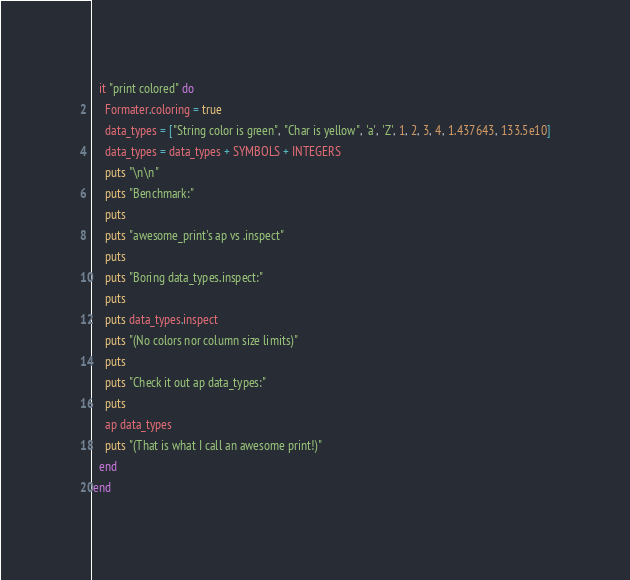Convert code to text. <code><loc_0><loc_0><loc_500><loc_500><_Crystal_>  it "print colored" do
    Formater.coloring = true
    data_types = ["String color is green", "Char is yellow", 'a', 'Z', 1, 2, 3, 4, 1.437643, 133.5e10]
    data_types = data_types + SYMBOLS + INTEGERS
    puts "\n\n"
    puts "Benchmark:"
    puts
    puts "awesome_print's ap vs .inspect"
    puts
    puts "Boring data_types.inspect:"
    puts
    puts data_types.inspect
    puts "(No colors nor column size limits)"
    puts
    puts "Check it out ap data_types:"
    puts
    ap data_types
    puts "(That is what I call an awesome print!)"
  end
end
</code> 